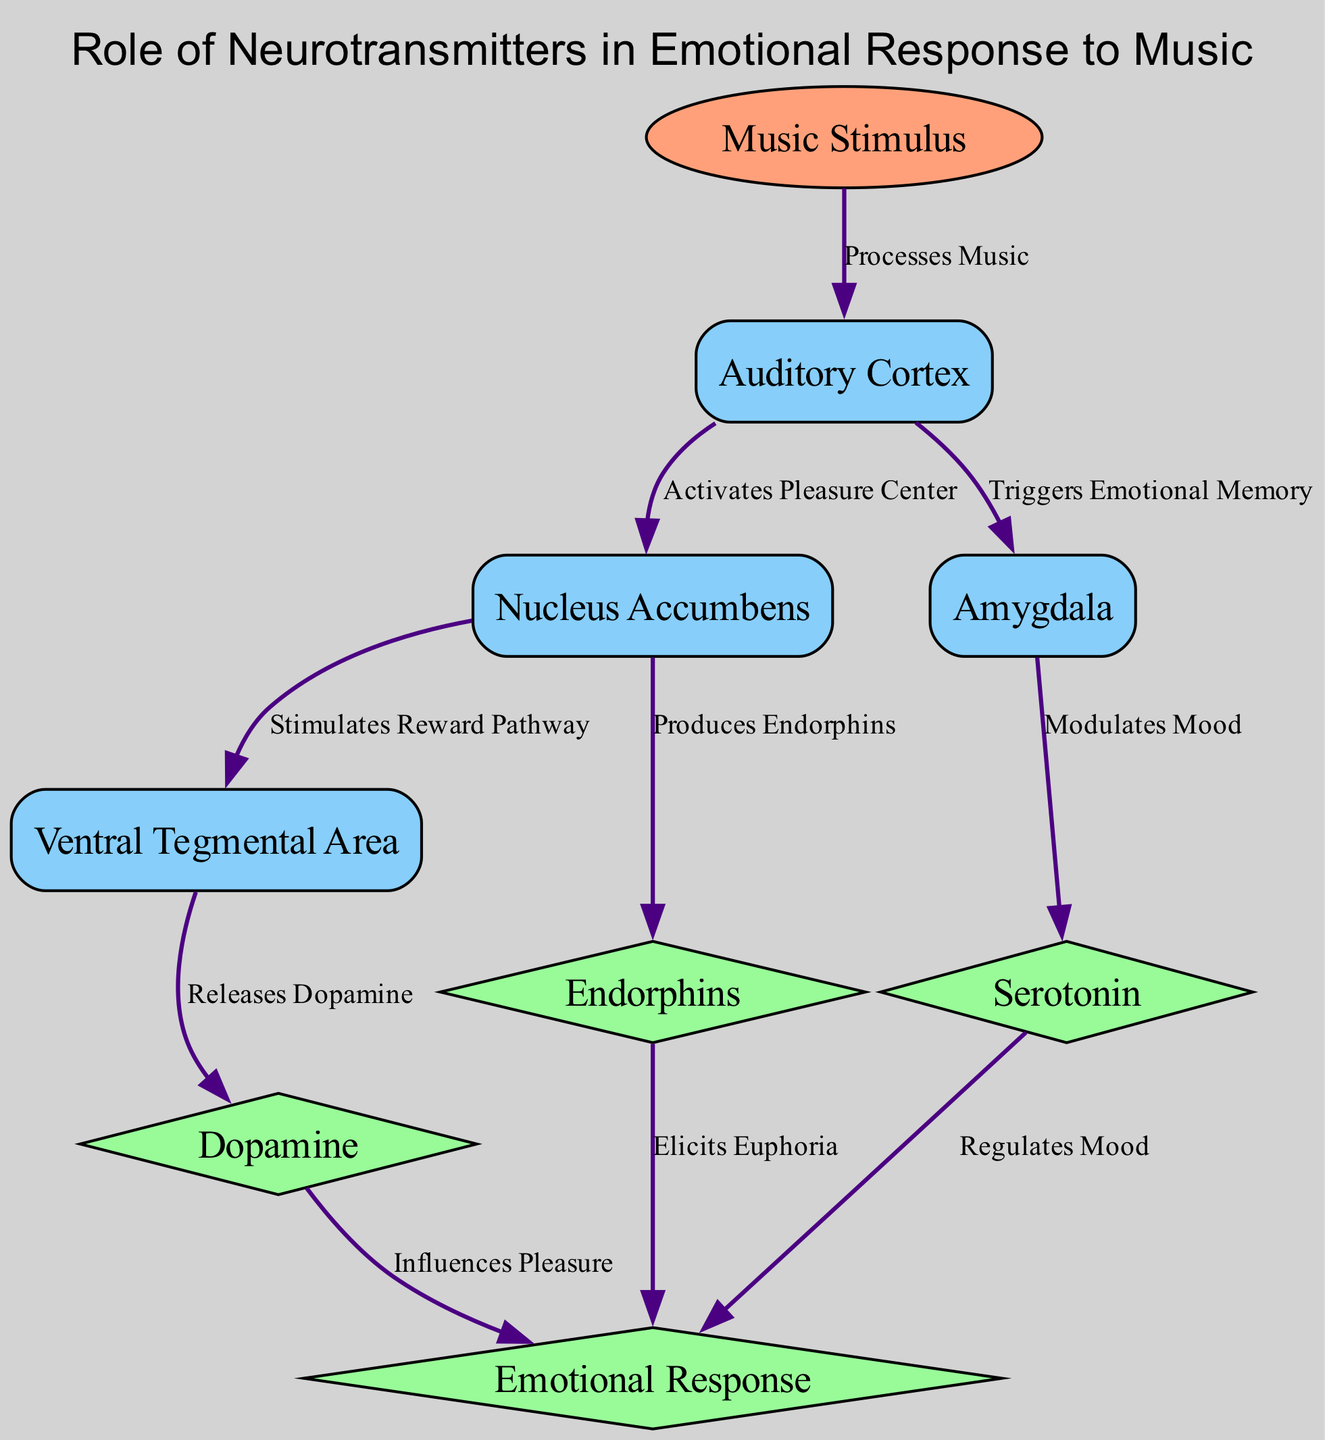what is the first node in the diagram? The first node listed in the diagram is "Music Stimulus," which is identified as the input node.
Answer: Music Stimulus how many output nodes are there? The diagram has three output nodes: Dopamine, Serotonin, and Endorphins, plus one additional node for Emotional Response. Therefore, counting these, there are four output nodes.
Answer: four what does the Auditory Cortex do? The Auditory Cortex processes the music stimulus as indicated in the edge description leading to the next nodes in the flow.
Answer: Processes Music which node triggers emotional memory? The edge leading from the Auditory Cortex to the Amygdala states that it triggers emotional memory, making the Amygdala responsible for this function.
Answer: Amygdala how does the Nucleus Accumbens influence dopamine release? The Nucleus Accumbens activates the Pleasure Center, which then stimulates the Reward Pathway towards the Ventral Tegmental Area, where dopamine is released.
Answer: Stimulates Reward Pathway what neurotransmitter is associated with mood regulation? The diagram indicates that Serotonin modulates mood as per the edge leading from the Amygdala to Serotonin.
Answer: Serotonin which process produces endorphins? The Nucleus Accumbens is connected to the production of endorphins based on the edge stated in the diagram.
Answer: Produces Endorphins how do dopamine and emotional response connect? The dopamine node influences the emotional response according to the edge leading from dopamine to emotional response, stating it influences pleasure.
Answer: Influences Pleasure what is the final output of the emotional response? The emotional response outputs are influenced by the dopamine, serotonin, and endorphins as separate pathways led by respective edges.
Answer: Dopamine, Serotonin, Endorphins 